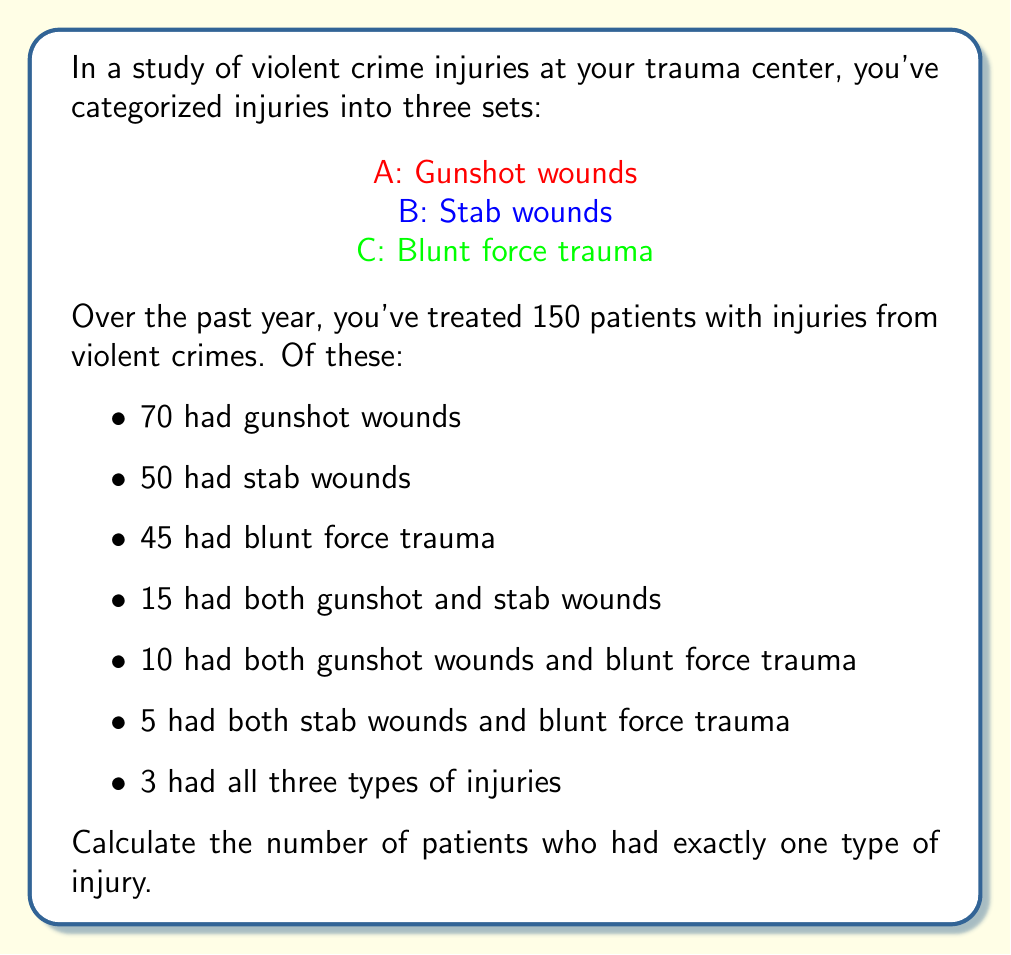Teach me how to tackle this problem. To solve this problem, we'll use the principle of inclusion-exclusion from set theory. Let's approach this step-by-step:

1) First, let's define the universe U as all patients treated for violent crime injuries:
   $|U| = 150$

2) We're given the following information:
   $|A| = 70$, $|B| = 50$, $|C| = 45$
   $|A \cap B| = 15$, $|A \cap C| = 10$, $|B \cap C| = 5$
   $|A \cap B \cap C| = 3$

3) The principle of inclusion-exclusion states:
   $$|A \cup B \cup C| = |A| + |B| + |C| - |A \cap B| - |A \cap C| - |B \cap C| + |A \cap B \cap C|$$

4) Let's calculate $|A \cup B \cup C|$:
   $$|A \cup B \cup C| = 70 + 50 + 45 - 15 - 10 - 5 + 3 = 138$$

5) This means 138 patients had at least one type of injury.

6) To find the number of patients with exactly one type of injury, we need to subtract those with more than one type from the total with at least one type:

   Patients with exactly one type = $|A \cup B \cup C| - $ (Patients with two types + Patients with all three types)

7) Patients with two types of injuries:
   $(|A \cap B| - |A \cap B \cap C|) + (|A \cap C| - |A \cap B \cap C|) + (|B \cap C| - |A \cap B \cap C|)$
   $= (15 - 3) + (10 - 3) + (5 - 3) = 12 + 7 + 2 = 21$

8) Patients with all three types: 3

9) Therefore, patients with exactly one type of injury:
   $138 - (21 + 3) = 114$
Answer: 114 patients had exactly one type of injury. 